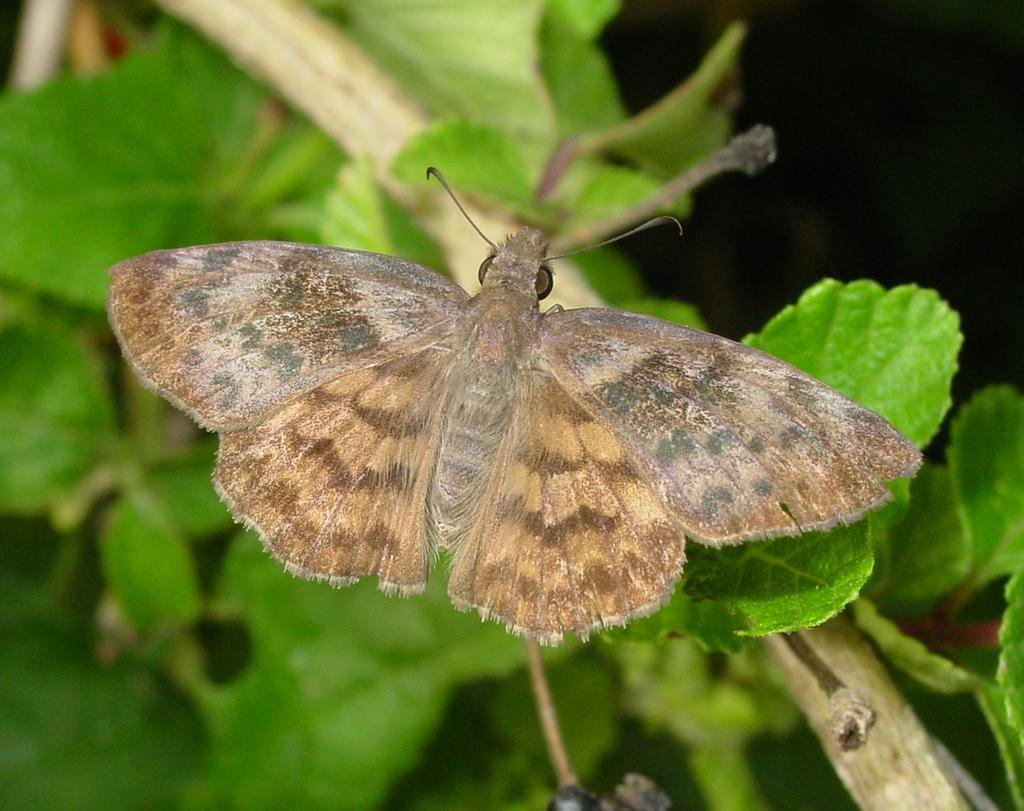What is present on the plant in the image? There is an insect on a plant in the image. What type of vegetation can be seen in the image? There are leaves visible in the image. What type of curtain is hanging from the tree in the image? There is no curtain or tree present in the image; it features an insect on a plant with leaves. What type of bottle is visible on the plant in the image? There is no bottle present in the image; it features an insect on a plant with leaves. 